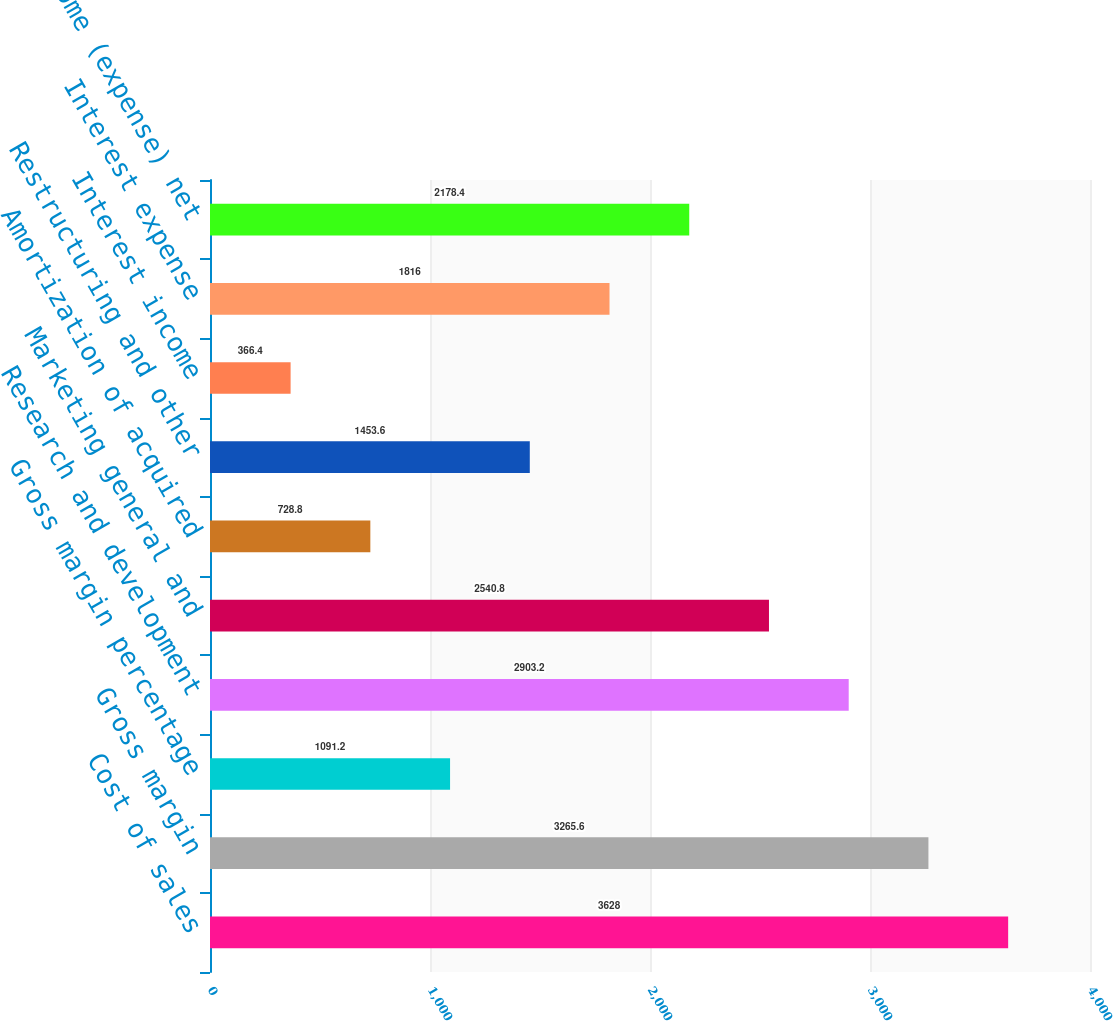<chart> <loc_0><loc_0><loc_500><loc_500><bar_chart><fcel>Cost of sales<fcel>Gross margin<fcel>Gross margin percentage<fcel>Research and development<fcel>Marketing general and<fcel>Amortization of acquired<fcel>Restructuring and other<fcel>Interest income<fcel>Interest expense<fcel>Other income (expense) net<nl><fcel>3628<fcel>3265.6<fcel>1091.2<fcel>2903.2<fcel>2540.8<fcel>728.8<fcel>1453.6<fcel>366.4<fcel>1816<fcel>2178.4<nl></chart> 